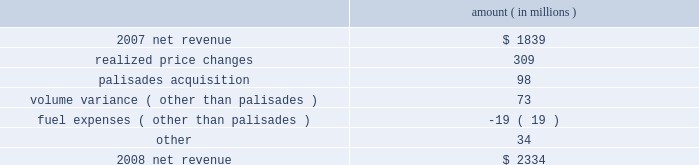Entergy corporation and subsidiaries management's financial discussion and analysis the purchased power capacity variance is primarily due to higher capacity charges .
A portion of the variance is due to the amortization of deferred capacity costs and is offset in base revenues due to base rate increases implemented to recover incremental deferred and ongoing purchased power capacity charges .
The volume/weather variance is primarily due to the effect of less favorable weather compared to the same period in 2007 and decreased electricity usage primarily during the unbilled sales period .
Hurricane gustav and hurricane ike , which hit the utility's service territories in september 2008 , contributed an estimated $ 46 million to the decrease in electricity usage .
Industrial sales were also depressed by the continuing effects of the hurricanes and , especially in the latter part of the year , because of the overall decline of the economy , leading to lower usage in the latter part of the year affecting both the large customer industrial segment as well as small and mid-sized industrial customers .
The decreases in electricity usage were partially offset by an increase in residential and commercial customer electricity usage that occurred during the periods of the year not affected by the hurricanes .
The retail electric price variance is primarily due to : an increase in the attala power plant costs recovered through the power management rider by entergy mississippi .
The net income effect of this recovery is limited to a portion representing an allowed return on equity with the remainder offset by attala power plant costs in other operation and maintenance expenses , depreciation expenses , and taxes other than income taxes ; a storm damage rider that became effective in october 2007 at entergy mississippi ; and an energy efficiency rider that became effective in november 2007 at entergy arkansas .
The establishment of the storm damage rider and the energy efficiency rider results in an increase in rider revenue and a corresponding increase in other operation and maintenance expense with no impact on net income .
The retail electric price variance was partially offset by : the absence of interim storm recoveries through the formula rate plans at entergy louisiana and entergy gulf states louisiana which ceased upon the act 55 financing of storm costs in the third quarter 2008 ; and a credit passed on to customers as a result of the act 55 storm cost financings .
Refer to "liquidity and capital resources - hurricane katrina and hurricane rita" below and note 2 to the financial statements for a discussion of the interim recovery of storm costs and the act 55 storm cost financings .
Non-utility nuclear following is an analysis of the change in net revenue comparing 2008 to 2007 .
Amount ( in millions ) .
As shown in the table above , net revenue for non-utility nuclear increased by $ 495 million , or 27% ( 27 % ) , in 2008 compared to 2007 primarily due to higher pricing in its contracts to sell power , additional production available from the acquisition of palisades in april 2007 , and fewer outage days .
In addition to the refueling outages shown in the .
What was the average net revenue between 2007 and 2008 in millions? 
Computations: (((2334 + 1839) + 2) / 2)
Answer: 2087.5. 